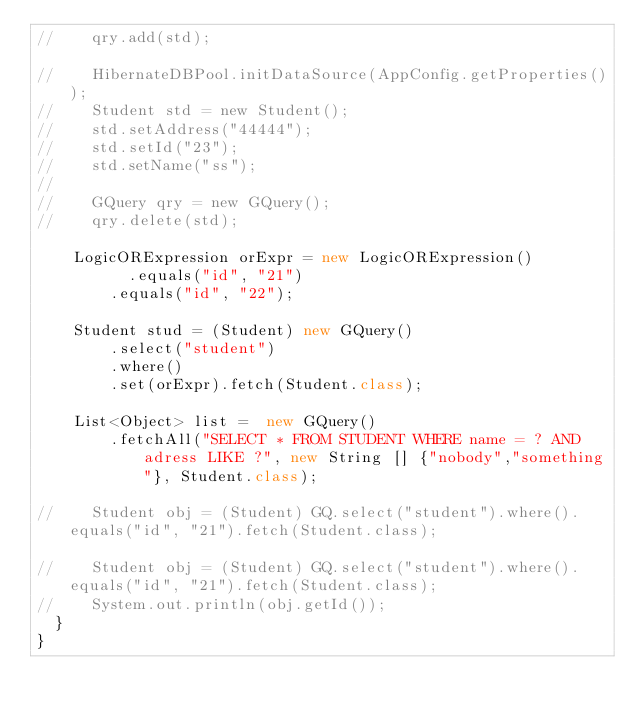Convert code to text. <code><loc_0><loc_0><loc_500><loc_500><_Java_>//		qry.add(std);

//		HibernateDBPool.initDataSource(AppConfig.getProperties());
//		Student std = new Student();
//		std.setAddress("44444");
//		std.setId("23");
//		std.setName("ss");
//
//		GQuery qry = new GQuery();
//		qry.delete(std);

		LogicORExpression orExpr = new LogicORExpression()
			    .equals("id", "21")
				.equals("id", "22");
		
		Student stud = (Student) new GQuery()
				.select("student")
				.where()
				.set(orExpr).fetch(Student.class);
		
		List<Object> list =  new GQuery()
				.fetchAll("SELECT * FROM STUDENT WHERE name = ? AND adress LIKE ?", new String [] {"nobody","something"}, Student.class);             
		
//		Student obj = (Student) GQ.select("student").where().equals("id", "21").fetch(Student.class);
		
//		Student obj = (Student) GQ.select("student").where().equals("id", "21").fetch(Student.class);
//		System.out.println(obj.getId());
	}
}
</code> 